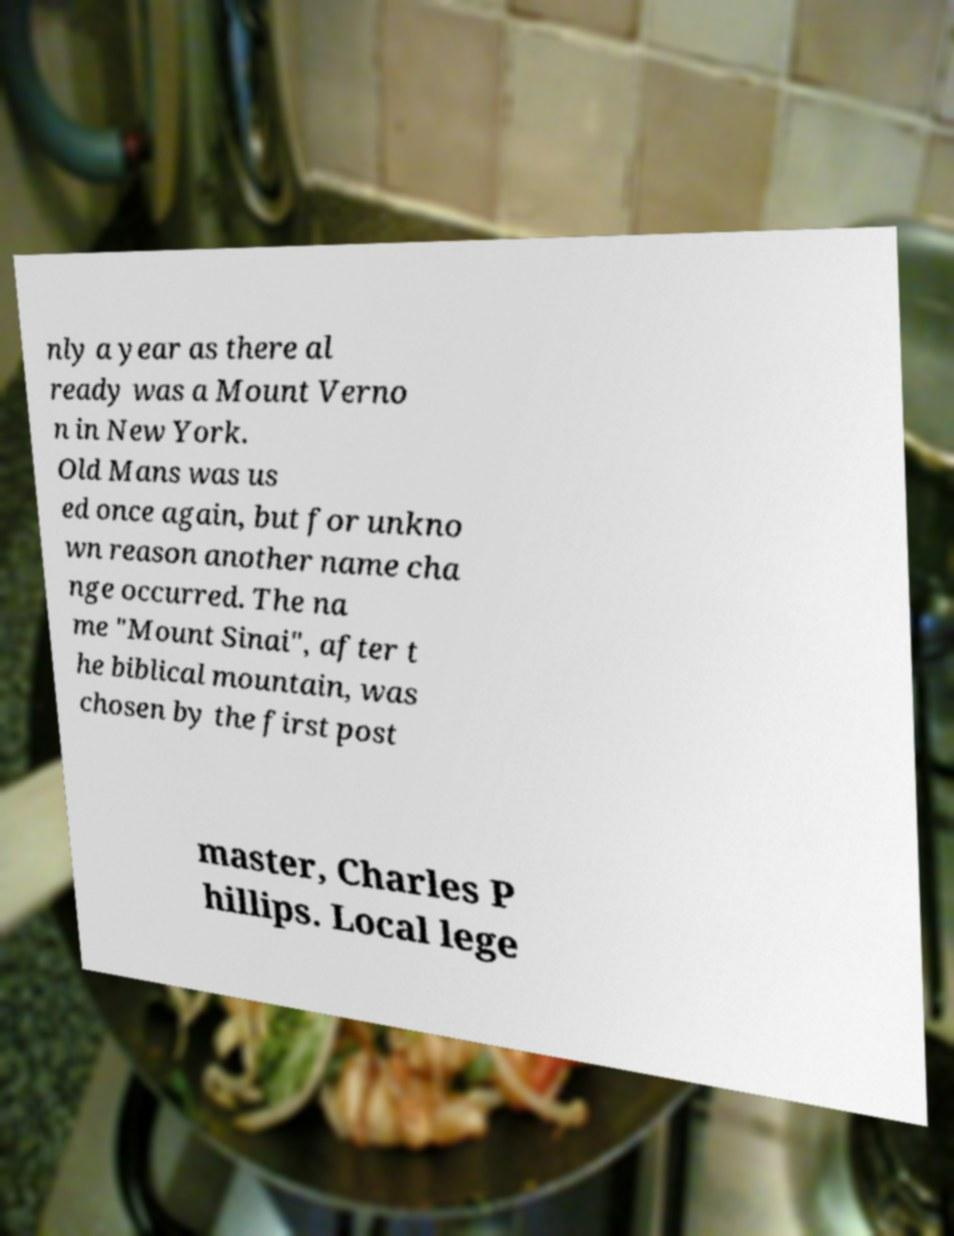Please read and relay the text visible in this image. What does it say? nly a year as there al ready was a Mount Verno n in New York. Old Mans was us ed once again, but for unkno wn reason another name cha nge occurred. The na me "Mount Sinai", after t he biblical mountain, was chosen by the first post master, Charles P hillips. Local lege 